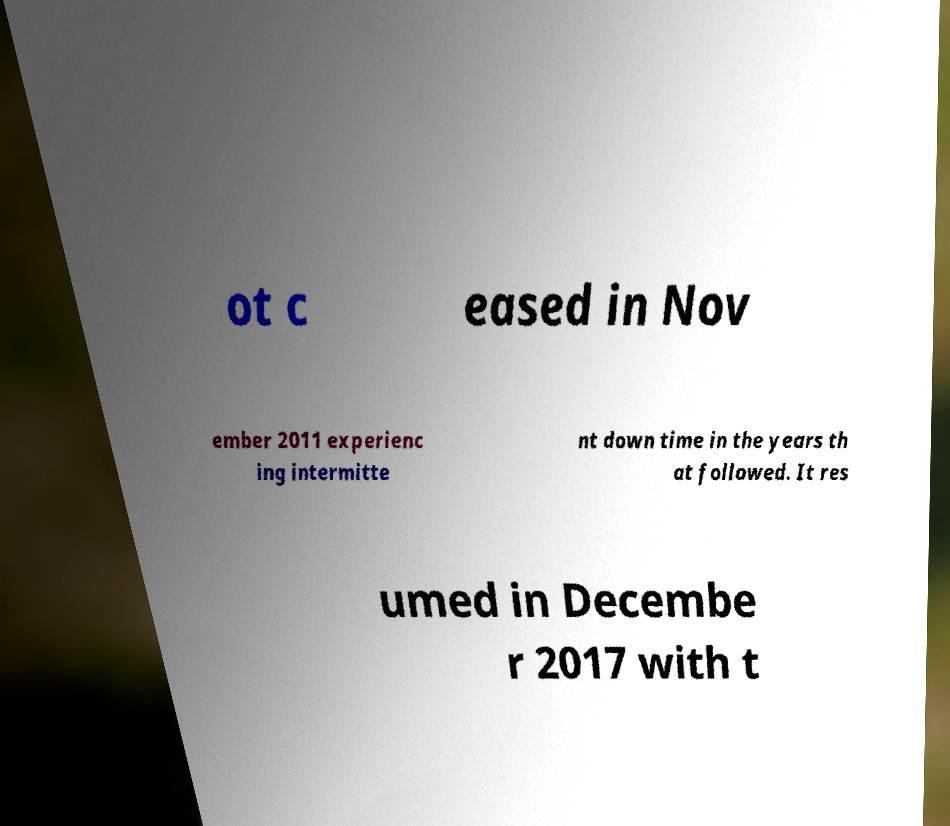Could you extract and type out the text from this image? ot c eased in Nov ember 2011 experienc ing intermitte nt down time in the years th at followed. It res umed in Decembe r 2017 with t 